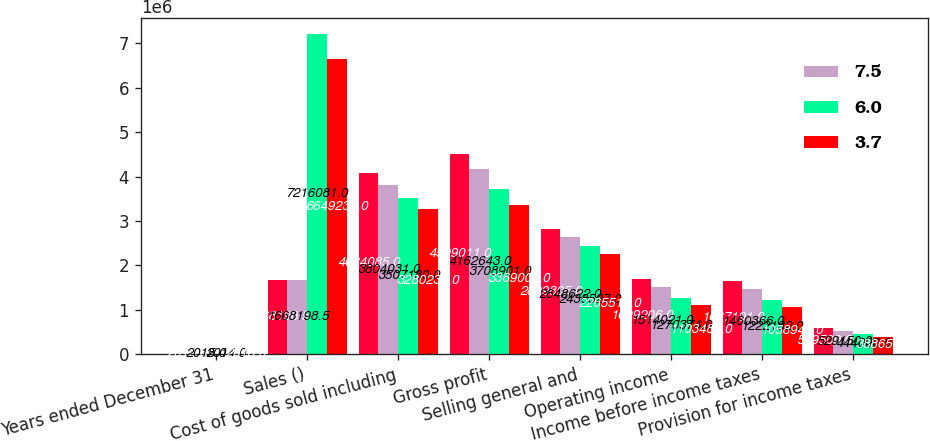Convert chart. <chart><loc_0><loc_0><loc_500><loc_500><stacked_bar_chart><ecel><fcel>Years ended December 31<fcel>Sales ()<fcel>Cost of goods sold including<fcel>Gross profit<fcel>Selling general and<fcel>Operating income<fcel>Income before income taxes<fcel>Provision for income taxes<nl><fcel>nan<fcel>2016<fcel>1.6682e+06<fcel>4.08408e+06<fcel>4.50901e+06<fcel>2.8098e+06<fcel>1.69921e+06<fcel>1.63719e+06<fcel>599500<nl><fcel>7.5<fcel>2015<fcel>1.6682e+06<fcel>3.80403e+06<fcel>4.16264e+06<fcel>2.64862e+06<fcel>1.51402e+06<fcel>1.46037e+06<fcel>529150<nl><fcel>6<fcel>2014<fcel>7.21608e+06<fcel>3.50718e+06<fcel>3.7089e+06<fcel>2.43853e+06<fcel>1.27037e+06<fcel>1.22218e+06<fcel>444000<nl><fcel>3.7<fcel>2013<fcel>6.64924e+06<fcel>3.28024e+06<fcel>3.369e+06<fcel>2.26552e+06<fcel>1.10348e+06<fcel>1.05894e+06<fcel>388650<nl></chart> 